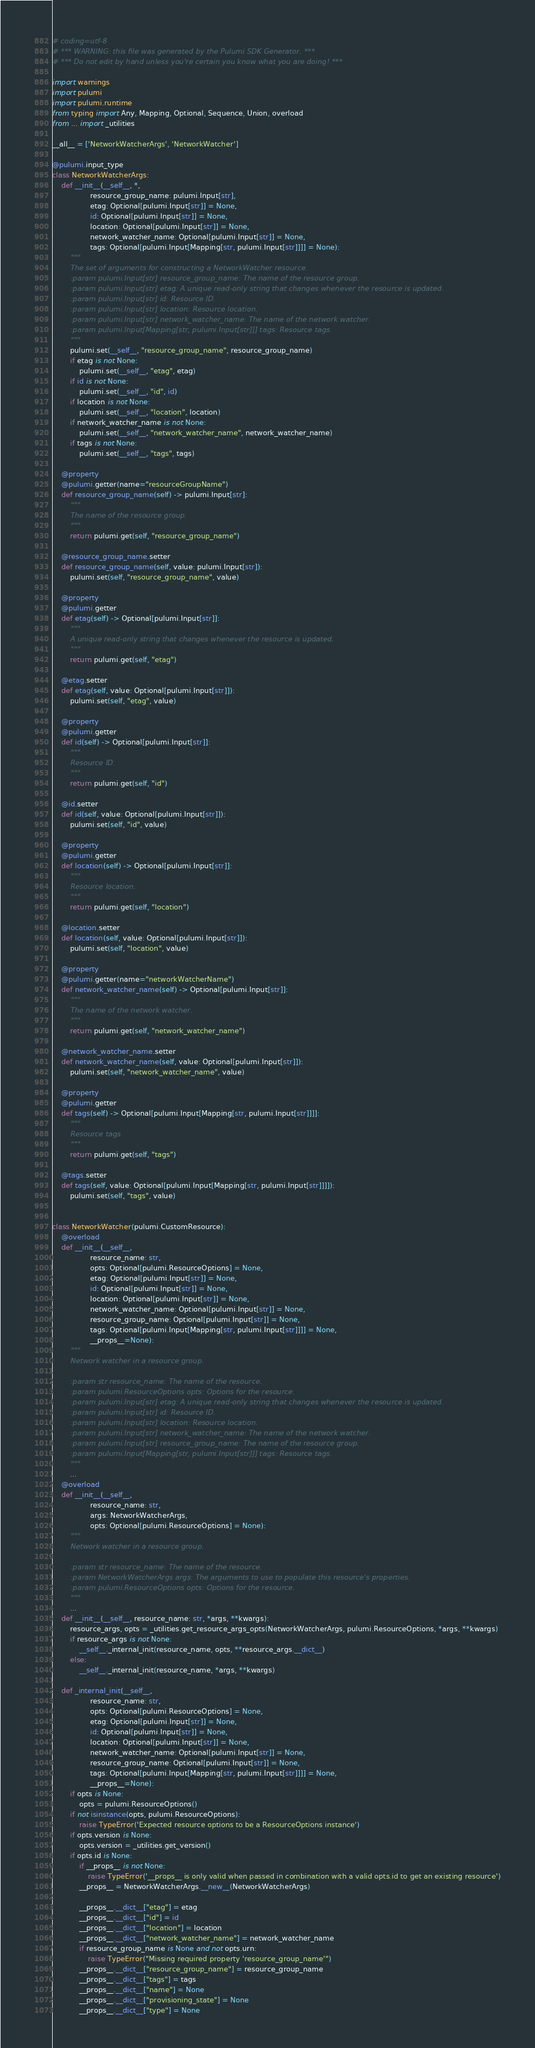<code> <loc_0><loc_0><loc_500><loc_500><_Python_># coding=utf-8
# *** WARNING: this file was generated by the Pulumi SDK Generator. ***
# *** Do not edit by hand unless you're certain you know what you are doing! ***

import warnings
import pulumi
import pulumi.runtime
from typing import Any, Mapping, Optional, Sequence, Union, overload
from ... import _utilities

__all__ = ['NetworkWatcherArgs', 'NetworkWatcher']

@pulumi.input_type
class NetworkWatcherArgs:
    def __init__(__self__, *,
                 resource_group_name: pulumi.Input[str],
                 etag: Optional[pulumi.Input[str]] = None,
                 id: Optional[pulumi.Input[str]] = None,
                 location: Optional[pulumi.Input[str]] = None,
                 network_watcher_name: Optional[pulumi.Input[str]] = None,
                 tags: Optional[pulumi.Input[Mapping[str, pulumi.Input[str]]]] = None):
        """
        The set of arguments for constructing a NetworkWatcher resource.
        :param pulumi.Input[str] resource_group_name: The name of the resource group.
        :param pulumi.Input[str] etag: A unique read-only string that changes whenever the resource is updated.
        :param pulumi.Input[str] id: Resource ID.
        :param pulumi.Input[str] location: Resource location.
        :param pulumi.Input[str] network_watcher_name: The name of the network watcher.
        :param pulumi.Input[Mapping[str, pulumi.Input[str]]] tags: Resource tags.
        """
        pulumi.set(__self__, "resource_group_name", resource_group_name)
        if etag is not None:
            pulumi.set(__self__, "etag", etag)
        if id is not None:
            pulumi.set(__self__, "id", id)
        if location is not None:
            pulumi.set(__self__, "location", location)
        if network_watcher_name is not None:
            pulumi.set(__self__, "network_watcher_name", network_watcher_name)
        if tags is not None:
            pulumi.set(__self__, "tags", tags)

    @property
    @pulumi.getter(name="resourceGroupName")
    def resource_group_name(self) -> pulumi.Input[str]:
        """
        The name of the resource group.
        """
        return pulumi.get(self, "resource_group_name")

    @resource_group_name.setter
    def resource_group_name(self, value: pulumi.Input[str]):
        pulumi.set(self, "resource_group_name", value)

    @property
    @pulumi.getter
    def etag(self) -> Optional[pulumi.Input[str]]:
        """
        A unique read-only string that changes whenever the resource is updated.
        """
        return pulumi.get(self, "etag")

    @etag.setter
    def etag(self, value: Optional[pulumi.Input[str]]):
        pulumi.set(self, "etag", value)

    @property
    @pulumi.getter
    def id(self) -> Optional[pulumi.Input[str]]:
        """
        Resource ID.
        """
        return pulumi.get(self, "id")

    @id.setter
    def id(self, value: Optional[pulumi.Input[str]]):
        pulumi.set(self, "id", value)

    @property
    @pulumi.getter
    def location(self) -> Optional[pulumi.Input[str]]:
        """
        Resource location.
        """
        return pulumi.get(self, "location")

    @location.setter
    def location(self, value: Optional[pulumi.Input[str]]):
        pulumi.set(self, "location", value)

    @property
    @pulumi.getter(name="networkWatcherName")
    def network_watcher_name(self) -> Optional[pulumi.Input[str]]:
        """
        The name of the network watcher.
        """
        return pulumi.get(self, "network_watcher_name")

    @network_watcher_name.setter
    def network_watcher_name(self, value: Optional[pulumi.Input[str]]):
        pulumi.set(self, "network_watcher_name", value)

    @property
    @pulumi.getter
    def tags(self) -> Optional[pulumi.Input[Mapping[str, pulumi.Input[str]]]]:
        """
        Resource tags.
        """
        return pulumi.get(self, "tags")

    @tags.setter
    def tags(self, value: Optional[pulumi.Input[Mapping[str, pulumi.Input[str]]]]):
        pulumi.set(self, "tags", value)


class NetworkWatcher(pulumi.CustomResource):
    @overload
    def __init__(__self__,
                 resource_name: str,
                 opts: Optional[pulumi.ResourceOptions] = None,
                 etag: Optional[pulumi.Input[str]] = None,
                 id: Optional[pulumi.Input[str]] = None,
                 location: Optional[pulumi.Input[str]] = None,
                 network_watcher_name: Optional[pulumi.Input[str]] = None,
                 resource_group_name: Optional[pulumi.Input[str]] = None,
                 tags: Optional[pulumi.Input[Mapping[str, pulumi.Input[str]]]] = None,
                 __props__=None):
        """
        Network watcher in a resource group.

        :param str resource_name: The name of the resource.
        :param pulumi.ResourceOptions opts: Options for the resource.
        :param pulumi.Input[str] etag: A unique read-only string that changes whenever the resource is updated.
        :param pulumi.Input[str] id: Resource ID.
        :param pulumi.Input[str] location: Resource location.
        :param pulumi.Input[str] network_watcher_name: The name of the network watcher.
        :param pulumi.Input[str] resource_group_name: The name of the resource group.
        :param pulumi.Input[Mapping[str, pulumi.Input[str]]] tags: Resource tags.
        """
        ...
    @overload
    def __init__(__self__,
                 resource_name: str,
                 args: NetworkWatcherArgs,
                 opts: Optional[pulumi.ResourceOptions] = None):
        """
        Network watcher in a resource group.

        :param str resource_name: The name of the resource.
        :param NetworkWatcherArgs args: The arguments to use to populate this resource's properties.
        :param pulumi.ResourceOptions opts: Options for the resource.
        """
        ...
    def __init__(__self__, resource_name: str, *args, **kwargs):
        resource_args, opts = _utilities.get_resource_args_opts(NetworkWatcherArgs, pulumi.ResourceOptions, *args, **kwargs)
        if resource_args is not None:
            __self__._internal_init(resource_name, opts, **resource_args.__dict__)
        else:
            __self__._internal_init(resource_name, *args, **kwargs)

    def _internal_init(__self__,
                 resource_name: str,
                 opts: Optional[pulumi.ResourceOptions] = None,
                 etag: Optional[pulumi.Input[str]] = None,
                 id: Optional[pulumi.Input[str]] = None,
                 location: Optional[pulumi.Input[str]] = None,
                 network_watcher_name: Optional[pulumi.Input[str]] = None,
                 resource_group_name: Optional[pulumi.Input[str]] = None,
                 tags: Optional[pulumi.Input[Mapping[str, pulumi.Input[str]]]] = None,
                 __props__=None):
        if opts is None:
            opts = pulumi.ResourceOptions()
        if not isinstance(opts, pulumi.ResourceOptions):
            raise TypeError('Expected resource options to be a ResourceOptions instance')
        if opts.version is None:
            opts.version = _utilities.get_version()
        if opts.id is None:
            if __props__ is not None:
                raise TypeError('__props__ is only valid when passed in combination with a valid opts.id to get an existing resource')
            __props__ = NetworkWatcherArgs.__new__(NetworkWatcherArgs)

            __props__.__dict__["etag"] = etag
            __props__.__dict__["id"] = id
            __props__.__dict__["location"] = location
            __props__.__dict__["network_watcher_name"] = network_watcher_name
            if resource_group_name is None and not opts.urn:
                raise TypeError("Missing required property 'resource_group_name'")
            __props__.__dict__["resource_group_name"] = resource_group_name
            __props__.__dict__["tags"] = tags
            __props__.__dict__["name"] = None
            __props__.__dict__["provisioning_state"] = None
            __props__.__dict__["type"] = None</code> 